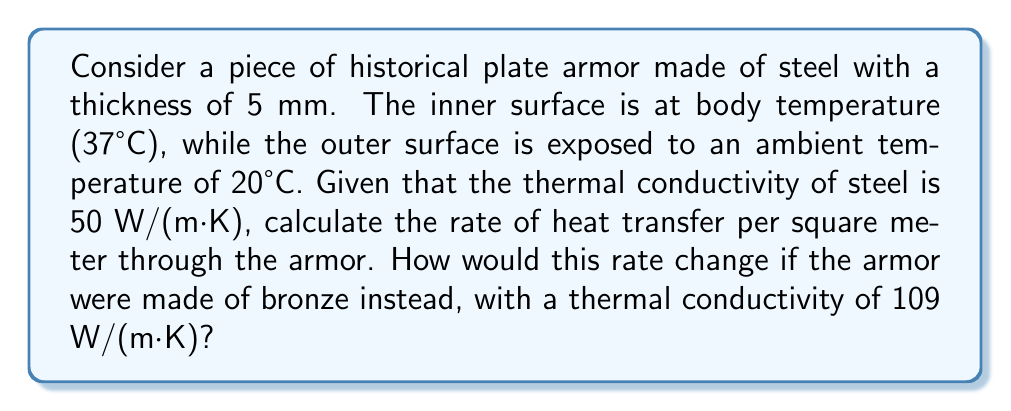Help me with this question. To solve this problem, we'll use Fourier's law of heat conduction:

$$q = -k \frac{dT}{dx}$$

Where:
$q$ = heat flux (W/m²)
$k$ = thermal conductivity (W/(m·K))
$\frac{dT}{dx}$ = temperature gradient (K/m)

For a flat plate with constant thermal conductivity, this simplifies to:

$$q = k \frac{T_2 - T_1}{L}$$

Where:
$T_2$ = temperature of the hot side (K)
$T_1$ = temperature of the cold side (K)
$L$ = thickness of the material (m)

Step 1: Calculate the heat transfer rate for steel armor
- $k_{steel} = 50$ W/(m·K)
- $T_2 = 37°C = 310.15$ K
- $T_1 = 20°C = 293.15$ K
- $L = 5$ mm $= 0.005$ m

$$q_{steel} = 50 \frac{310.15 - 293.15}{0.005} = 170,000 \text{ W/m²}$$

Step 2: Calculate the heat transfer rate for bronze armor
- $k_{bronze} = 109$ W/(m·K)
- All other variables remain the same

$$q_{bronze} = 109 \frac{310.15 - 293.15}{0.005} = 370,600 \text{ W/m²}$$

Step 3: Calculate the difference in heat transfer rates
$$\text{Difference} = q_{bronze} - q_{steel} = 370,600 - 170,000 = 200,600 \text{ W/m²}$$

The heat transfer rate through bronze armor is 200,600 W/m² higher than through steel armor of the same thickness.
Answer: Steel: 170,000 W/m²; Bronze: 370,600 W/m²; Difference: 200,600 W/m² 